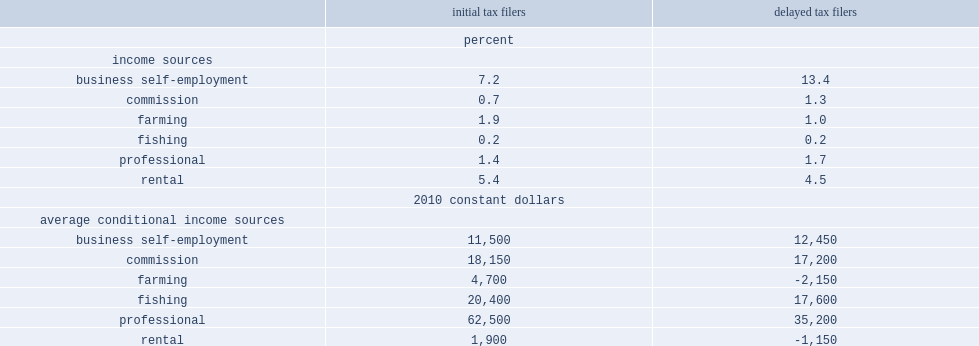Who were more likely to have business self-employment income, initial tax filers or delayed tax filers? Delayed tax filers. Who were more likely to have commission income, initial tax filers or delayed tax filers? Delayed tax filers. Who were more likely to have farming income, initial tax filers or delayed tax filers? Initial tax filers. What was the margin between initial and delayed tax filers for fishing income? 0. Who were more likely to earn more for business self-employment income, initial tax filers or delayed tax filers? Delayed tax filers. Who were more likely to earn more for professional income, initial tax filers or delayed tax filers? Initial tax filers. 